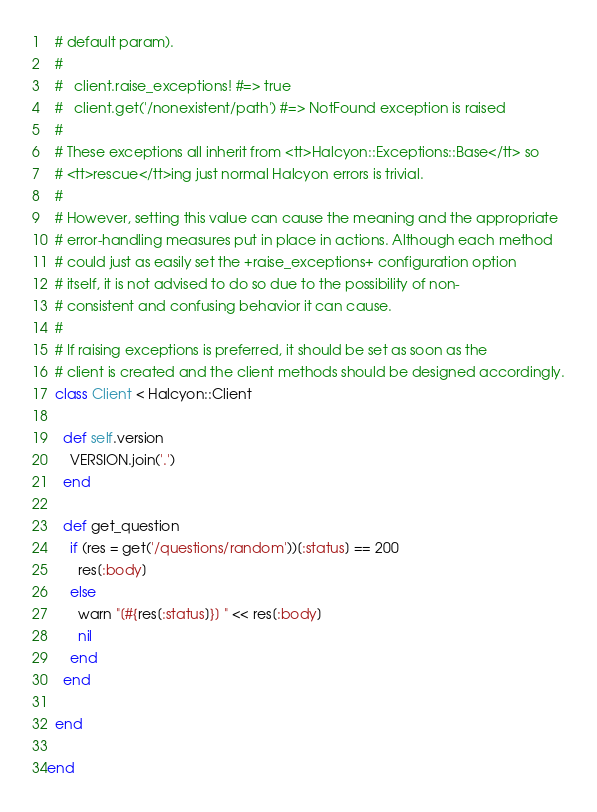Convert code to text. <code><loc_0><loc_0><loc_500><loc_500><_Ruby_>  # default param).
  # 
  #   client.raise_exceptions! #=> true
  #   client.get('/nonexistent/path') #=> NotFound exception is raised
  # 
  # These exceptions all inherit from <tt>Halcyon::Exceptions::Base</tt> so
  # <tt>rescue</tt>ing just normal Halcyon errors is trivial.
  # 
  # However, setting this value can cause the meaning and the appropriate
  # error-handling measures put in place in actions. Although each method
  # could just as easily set the +raise_exceptions+ configuration option
  # itself, it is not advised to do so due to the possibility of non-
  # consistent and confusing behavior it can cause.
  # 
  # If raising exceptions is preferred, it should be set as soon as the
  # client is created and the client methods should be designed accordingly.
  class Client < Halcyon::Client
    
    def self.version
      VERSION.join('.')
    end
    
    def get_question
      if (res = get('/questions/random'))[:status] == 200
        res[:body]
      else
        warn "[#{res[:status]}] " << res[:body]
        nil
      end
    end
    
  end
  
end
</code> 